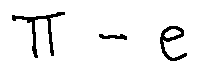<formula> <loc_0><loc_0><loc_500><loc_500>\pi - e</formula> 